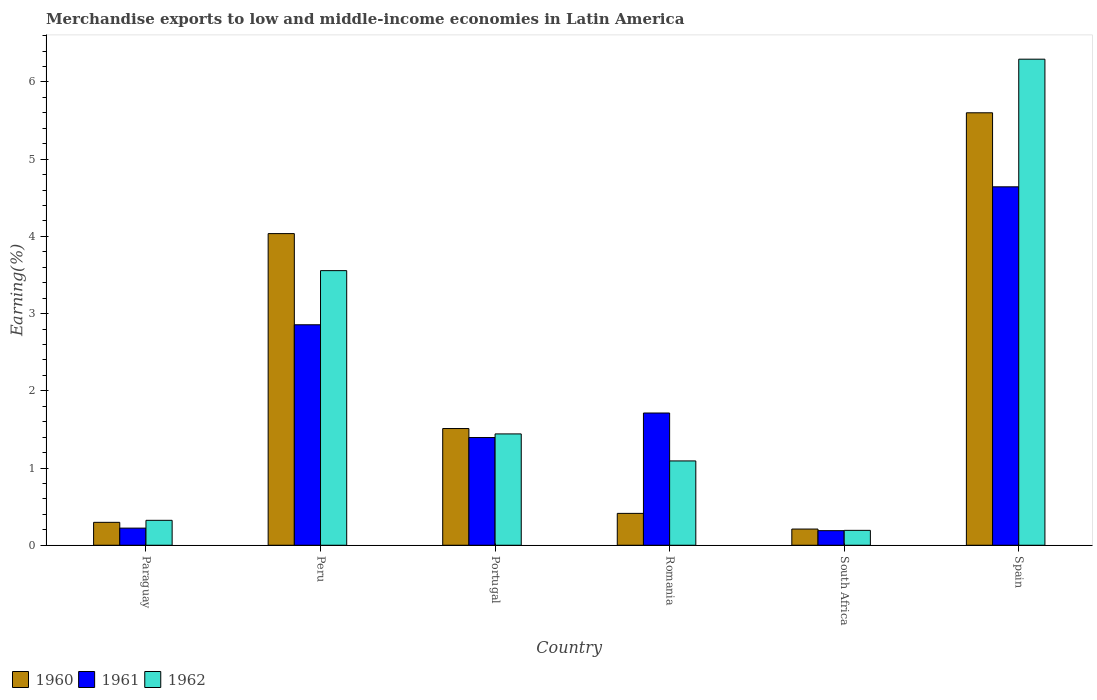How many different coloured bars are there?
Your answer should be compact. 3. Are the number of bars per tick equal to the number of legend labels?
Offer a terse response. Yes. Are the number of bars on each tick of the X-axis equal?
Give a very brief answer. Yes. How many bars are there on the 1st tick from the left?
Ensure brevity in your answer.  3. What is the label of the 4th group of bars from the left?
Ensure brevity in your answer.  Romania. In how many cases, is the number of bars for a given country not equal to the number of legend labels?
Your answer should be very brief. 0. What is the percentage of amount earned from merchandise exports in 1960 in Peru?
Ensure brevity in your answer.  4.04. Across all countries, what is the maximum percentage of amount earned from merchandise exports in 1960?
Your answer should be very brief. 5.6. Across all countries, what is the minimum percentage of amount earned from merchandise exports in 1961?
Your response must be concise. 0.19. In which country was the percentage of amount earned from merchandise exports in 1961 minimum?
Give a very brief answer. South Africa. What is the total percentage of amount earned from merchandise exports in 1962 in the graph?
Provide a succinct answer. 12.9. What is the difference between the percentage of amount earned from merchandise exports in 1962 in Peru and that in Romania?
Offer a very short reply. 2.46. What is the difference between the percentage of amount earned from merchandise exports in 1962 in Peru and the percentage of amount earned from merchandise exports in 1960 in Spain?
Keep it short and to the point. -2.04. What is the average percentage of amount earned from merchandise exports in 1962 per country?
Your response must be concise. 2.15. What is the difference between the percentage of amount earned from merchandise exports of/in 1961 and percentage of amount earned from merchandise exports of/in 1960 in Peru?
Your answer should be very brief. -1.18. What is the ratio of the percentage of amount earned from merchandise exports in 1962 in Portugal to that in Spain?
Make the answer very short. 0.23. Is the difference between the percentage of amount earned from merchandise exports in 1961 in Romania and South Africa greater than the difference between the percentage of amount earned from merchandise exports in 1960 in Romania and South Africa?
Your response must be concise. Yes. What is the difference between the highest and the second highest percentage of amount earned from merchandise exports in 1960?
Give a very brief answer. -2.52. What is the difference between the highest and the lowest percentage of amount earned from merchandise exports in 1960?
Ensure brevity in your answer.  5.39. In how many countries, is the percentage of amount earned from merchandise exports in 1961 greater than the average percentage of amount earned from merchandise exports in 1961 taken over all countries?
Offer a very short reply. 2. What does the 3rd bar from the left in Peru represents?
Offer a very short reply. 1962. Is it the case that in every country, the sum of the percentage of amount earned from merchandise exports in 1962 and percentage of amount earned from merchandise exports in 1961 is greater than the percentage of amount earned from merchandise exports in 1960?
Offer a very short reply. Yes. How many bars are there?
Your answer should be very brief. 18. What is the difference between two consecutive major ticks on the Y-axis?
Offer a very short reply. 1. How many legend labels are there?
Make the answer very short. 3. How are the legend labels stacked?
Give a very brief answer. Horizontal. What is the title of the graph?
Provide a short and direct response. Merchandise exports to low and middle-income economies in Latin America. What is the label or title of the Y-axis?
Your response must be concise. Earning(%). What is the Earning(%) in 1960 in Paraguay?
Your answer should be very brief. 0.3. What is the Earning(%) of 1961 in Paraguay?
Provide a short and direct response. 0.22. What is the Earning(%) of 1962 in Paraguay?
Your answer should be compact. 0.32. What is the Earning(%) of 1960 in Peru?
Provide a succinct answer. 4.04. What is the Earning(%) in 1961 in Peru?
Your response must be concise. 2.86. What is the Earning(%) in 1962 in Peru?
Ensure brevity in your answer.  3.56. What is the Earning(%) in 1960 in Portugal?
Offer a terse response. 1.51. What is the Earning(%) in 1961 in Portugal?
Provide a short and direct response. 1.39. What is the Earning(%) of 1962 in Portugal?
Your response must be concise. 1.44. What is the Earning(%) in 1960 in Romania?
Keep it short and to the point. 0.41. What is the Earning(%) of 1961 in Romania?
Provide a succinct answer. 1.71. What is the Earning(%) of 1962 in Romania?
Provide a succinct answer. 1.09. What is the Earning(%) in 1960 in South Africa?
Your answer should be compact. 0.21. What is the Earning(%) in 1961 in South Africa?
Provide a short and direct response. 0.19. What is the Earning(%) of 1962 in South Africa?
Your answer should be very brief. 0.19. What is the Earning(%) of 1960 in Spain?
Provide a short and direct response. 5.6. What is the Earning(%) of 1961 in Spain?
Ensure brevity in your answer.  4.64. What is the Earning(%) of 1962 in Spain?
Give a very brief answer. 6.3. Across all countries, what is the maximum Earning(%) of 1960?
Your answer should be very brief. 5.6. Across all countries, what is the maximum Earning(%) of 1961?
Provide a short and direct response. 4.64. Across all countries, what is the maximum Earning(%) in 1962?
Your answer should be very brief. 6.3. Across all countries, what is the minimum Earning(%) in 1960?
Your response must be concise. 0.21. Across all countries, what is the minimum Earning(%) of 1961?
Give a very brief answer. 0.19. Across all countries, what is the minimum Earning(%) of 1962?
Keep it short and to the point. 0.19. What is the total Earning(%) of 1960 in the graph?
Offer a terse response. 12.07. What is the total Earning(%) in 1961 in the graph?
Your answer should be very brief. 11.02. What is the total Earning(%) of 1962 in the graph?
Your response must be concise. 12.9. What is the difference between the Earning(%) in 1960 in Paraguay and that in Peru?
Your answer should be compact. -3.74. What is the difference between the Earning(%) in 1961 in Paraguay and that in Peru?
Provide a short and direct response. -2.63. What is the difference between the Earning(%) in 1962 in Paraguay and that in Peru?
Ensure brevity in your answer.  -3.23. What is the difference between the Earning(%) of 1960 in Paraguay and that in Portugal?
Your answer should be very brief. -1.21. What is the difference between the Earning(%) of 1961 in Paraguay and that in Portugal?
Your response must be concise. -1.17. What is the difference between the Earning(%) of 1962 in Paraguay and that in Portugal?
Your answer should be compact. -1.12. What is the difference between the Earning(%) of 1960 in Paraguay and that in Romania?
Offer a terse response. -0.12. What is the difference between the Earning(%) of 1961 in Paraguay and that in Romania?
Ensure brevity in your answer.  -1.49. What is the difference between the Earning(%) of 1962 in Paraguay and that in Romania?
Ensure brevity in your answer.  -0.77. What is the difference between the Earning(%) of 1960 in Paraguay and that in South Africa?
Your answer should be very brief. 0.09. What is the difference between the Earning(%) in 1961 in Paraguay and that in South Africa?
Provide a succinct answer. 0.03. What is the difference between the Earning(%) of 1962 in Paraguay and that in South Africa?
Your answer should be compact. 0.13. What is the difference between the Earning(%) in 1960 in Paraguay and that in Spain?
Ensure brevity in your answer.  -5.3. What is the difference between the Earning(%) in 1961 in Paraguay and that in Spain?
Provide a short and direct response. -4.42. What is the difference between the Earning(%) of 1962 in Paraguay and that in Spain?
Provide a succinct answer. -5.97. What is the difference between the Earning(%) in 1960 in Peru and that in Portugal?
Provide a short and direct response. 2.52. What is the difference between the Earning(%) in 1961 in Peru and that in Portugal?
Keep it short and to the point. 1.46. What is the difference between the Earning(%) in 1962 in Peru and that in Portugal?
Provide a succinct answer. 2.11. What is the difference between the Earning(%) in 1960 in Peru and that in Romania?
Offer a very short reply. 3.62. What is the difference between the Earning(%) of 1961 in Peru and that in Romania?
Keep it short and to the point. 1.14. What is the difference between the Earning(%) of 1962 in Peru and that in Romania?
Your answer should be compact. 2.46. What is the difference between the Earning(%) in 1960 in Peru and that in South Africa?
Offer a terse response. 3.83. What is the difference between the Earning(%) of 1961 in Peru and that in South Africa?
Ensure brevity in your answer.  2.67. What is the difference between the Earning(%) in 1962 in Peru and that in South Africa?
Your answer should be very brief. 3.36. What is the difference between the Earning(%) in 1960 in Peru and that in Spain?
Give a very brief answer. -1.56. What is the difference between the Earning(%) of 1961 in Peru and that in Spain?
Offer a very short reply. -1.79. What is the difference between the Earning(%) in 1962 in Peru and that in Spain?
Ensure brevity in your answer.  -2.74. What is the difference between the Earning(%) of 1960 in Portugal and that in Romania?
Ensure brevity in your answer.  1.1. What is the difference between the Earning(%) of 1961 in Portugal and that in Romania?
Your answer should be compact. -0.32. What is the difference between the Earning(%) of 1962 in Portugal and that in Romania?
Your answer should be compact. 0.35. What is the difference between the Earning(%) in 1960 in Portugal and that in South Africa?
Ensure brevity in your answer.  1.3. What is the difference between the Earning(%) in 1961 in Portugal and that in South Africa?
Your answer should be compact. 1.21. What is the difference between the Earning(%) of 1962 in Portugal and that in South Africa?
Keep it short and to the point. 1.25. What is the difference between the Earning(%) of 1960 in Portugal and that in Spain?
Ensure brevity in your answer.  -4.09. What is the difference between the Earning(%) of 1961 in Portugal and that in Spain?
Your answer should be very brief. -3.25. What is the difference between the Earning(%) in 1962 in Portugal and that in Spain?
Provide a short and direct response. -4.85. What is the difference between the Earning(%) in 1960 in Romania and that in South Africa?
Offer a very short reply. 0.2. What is the difference between the Earning(%) of 1961 in Romania and that in South Africa?
Your answer should be compact. 1.52. What is the difference between the Earning(%) in 1962 in Romania and that in South Africa?
Offer a terse response. 0.9. What is the difference between the Earning(%) of 1960 in Romania and that in Spain?
Your answer should be very brief. -5.19. What is the difference between the Earning(%) in 1961 in Romania and that in Spain?
Ensure brevity in your answer.  -2.93. What is the difference between the Earning(%) in 1962 in Romania and that in Spain?
Your answer should be compact. -5.2. What is the difference between the Earning(%) in 1960 in South Africa and that in Spain?
Offer a terse response. -5.39. What is the difference between the Earning(%) in 1961 in South Africa and that in Spain?
Ensure brevity in your answer.  -4.45. What is the difference between the Earning(%) in 1962 in South Africa and that in Spain?
Provide a short and direct response. -6.1. What is the difference between the Earning(%) in 1960 in Paraguay and the Earning(%) in 1961 in Peru?
Ensure brevity in your answer.  -2.56. What is the difference between the Earning(%) in 1960 in Paraguay and the Earning(%) in 1962 in Peru?
Provide a succinct answer. -3.26. What is the difference between the Earning(%) in 1961 in Paraguay and the Earning(%) in 1962 in Peru?
Make the answer very short. -3.33. What is the difference between the Earning(%) of 1960 in Paraguay and the Earning(%) of 1961 in Portugal?
Your answer should be very brief. -1.1. What is the difference between the Earning(%) of 1960 in Paraguay and the Earning(%) of 1962 in Portugal?
Give a very brief answer. -1.15. What is the difference between the Earning(%) of 1961 in Paraguay and the Earning(%) of 1962 in Portugal?
Your answer should be very brief. -1.22. What is the difference between the Earning(%) in 1960 in Paraguay and the Earning(%) in 1961 in Romania?
Provide a short and direct response. -1.42. What is the difference between the Earning(%) in 1960 in Paraguay and the Earning(%) in 1962 in Romania?
Give a very brief answer. -0.8. What is the difference between the Earning(%) in 1961 in Paraguay and the Earning(%) in 1962 in Romania?
Your answer should be very brief. -0.87. What is the difference between the Earning(%) in 1960 in Paraguay and the Earning(%) in 1961 in South Africa?
Offer a terse response. 0.11. What is the difference between the Earning(%) in 1960 in Paraguay and the Earning(%) in 1962 in South Africa?
Your answer should be very brief. 0.1. What is the difference between the Earning(%) of 1961 in Paraguay and the Earning(%) of 1962 in South Africa?
Offer a terse response. 0.03. What is the difference between the Earning(%) in 1960 in Paraguay and the Earning(%) in 1961 in Spain?
Make the answer very short. -4.35. What is the difference between the Earning(%) in 1960 in Paraguay and the Earning(%) in 1962 in Spain?
Provide a short and direct response. -6. What is the difference between the Earning(%) in 1961 in Paraguay and the Earning(%) in 1962 in Spain?
Give a very brief answer. -6.07. What is the difference between the Earning(%) of 1960 in Peru and the Earning(%) of 1961 in Portugal?
Offer a very short reply. 2.64. What is the difference between the Earning(%) of 1960 in Peru and the Earning(%) of 1962 in Portugal?
Give a very brief answer. 2.59. What is the difference between the Earning(%) in 1961 in Peru and the Earning(%) in 1962 in Portugal?
Offer a very short reply. 1.41. What is the difference between the Earning(%) of 1960 in Peru and the Earning(%) of 1961 in Romania?
Your answer should be very brief. 2.32. What is the difference between the Earning(%) in 1960 in Peru and the Earning(%) in 1962 in Romania?
Make the answer very short. 2.94. What is the difference between the Earning(%) of 1961 in Peru and the Earning(%) of 1962 in Romania?
Your answer should be compact. 1.76. What is the difference between the Earning(%) of 1960 in Peru and the Earning(%) of 1961 in South Africa?
Keep it short and to the point. 3.85. What is the difference between the Earning(%) in 1960 in Peru and the Earning(%) in 1962 in South Africa?
Give a very brief answer. 3.84. What is the difference between the Earning(%) in 1961 in Peru and the Earning(%) in 1962 in South Africa?
Make the answer very short. 2.66. What is the difference between the Earning(%) of 1960 in Peru and the Earning(%) of 1961 in Spain?
Offer a very short reply. -0.61. What is the difference between the Earning(%) of 1960 in Peru and the Earning(%) of 1962 in Spain?
Your response must be concise. -2.26. What is the difference between the Earning(%) in 1961 in Peru and the Earning(%) in 1962 in Spain?
Offer a terse response. -3.44. What is the difference between the Earning(%) in 1960 in Portugal and the Earning(%) in 1961 in Romania?
Make the answer very short. -0.2. What is the difference between the Earning(%) in 1960 in Portugal and the Earning(%) in 1962 in Romania?
Your response must be concise. 0.42. What is the difference between the Earning(%) in 1961 in Portugal and the Earning(%) in 1962 in Romania?
Offer a very short reply. 0.3. What is the difference between the Earning(%) of 1960 in Portugal and the Earning(%) of 1961 in South Africa?
Provide a succinct answer. 1.32. What is the difference between the Earning(%) of 1960 in Portugal and the Earning(%) of 1962 in South Africa?
Offer a terse response. 1.32. What is the difference between the Earning(%) in 1961 in Portugal and the Earning(%) in 1962 in South Africa?
Make the answer very short. 1.2. What is the difference between the Earning(%) of 1960 in Portugal and the Earning(%) of 1961 in Spain?
Offer a terse response. -3.13. What is the difference between the Earning(%) of 1960 in Portugal and the Earning(%) of 1962 in Spain?
Your answer should be compact. -4.78. What is the difference between the Earning(%) of 1961 in Portugal and the Earning(%) of 1962 in Spain?
Provide a short and direct response. -4.9. What is the difference between the Earning(%) of 1960 in Romania and the Earning(%) of 1961 in South Africa?
Offer a terse response. 0.22. What is the difference between the Earning(%) in 1960 in Romania and the Earning(%) in 1962 in South Africa?
Give a very brief answer. 0.22. What is the difference between the Earning(%) in 1961 in Romania and the Earning(%) in 1962 in South Africa?
Offer a terse response. 1.52. What is the difference between the Earning(%) of 1960 in Romania and the Earning(%) of 1961 in Spain?
Offer a terse response. -4.23. What is the difference between the Earning(%) in 1960 in Romania and the Earning(%) in 1962 in Spain?
Offer a terse response. -5.88. What is the difference between the Earning(%) of 1961 in Romania and the Earning(%) of 1962 in Spain?
Your answer should be very brief. -4.58. What is the difference between the Earning(%) of 1960 in South Africa and the Earning(%) of 1961 in Spain?
Ensure brevity in your answer.  -4.43. What is the difference between the Earning(%) of 1960 in South Africa and the Earning(%) of 1962 in Spain?
Your response must be concise. -6.09. What is the difference between the Earning(%) in 1961 in South Africa and the Earning(%) in 1962 in Spain?
Offer a very short reply. -6.11. What is the average Earning(%) in 1960 per country?
Offer a terse response. 2.01. What is the average Earning(%) in 1961 per country?
Keep it short and to the point. 1.84. What is the average Earning(%) of 1962 per country?
Your response must be concise. 2.15. What is the difference between the Earning(%) in 1960 and Earning(%) in 1961 in Paraguay?
Provide a short and direct response. 0.07. What is the difference between the Earning(%) in 1960 and Earning(%) in 1962 in Paraguay?
Offer a very short reply. -0.03. What is the difference between the Earning(%) of 1961 and Earning(%) of 1962 in Paraguay?
Ensure brevity in your answer.  -0.1. What is the difference between the Earning(%) in 1960 and Earning(%) in 1961 in Peru?
Offer a terse response. 1.18. What is the difference between the Earning(%) in 1960 and Earning(%) in 1962 in Peru?
Make the answer very short. 0.48. What is the difference between the Earning(%) in 1961 and Earning(%) in 1962 in Peru?
Provide a succinct answer. -0.7. What is the difference between the Earning(%) in 1960 and Earning(%) in 1961 in Portugal?
Your response must be concise. 0.12. What is the difference between the Earning(%) of 1960 and Earning(%) of 1962 in Portugal?
Offer a very short reply. 0.07. What is the difference between the Earning(%) of 1961 and Earning(%) of 1962 in Portugal?
Ensure brevity in your answer.  -0.05. What is the difference between the Earning(%) in 1960 and Earning(%) in 1961 in Romania?
Offer a terse response. -1.3. What is the difference between the Earning(%) in 1960 and Earning(%) in 1962 in Romania?
Your answer should be very brief. -0.68. What is the difference between the Earning(%) in 1961 and Earning(%) in 1962 in Romania?
Offer a very short reply. 0.62. What is the difference between the Earning(%) in 1960 and Earning(%) in 1961 in South Africa?
Offer a terse response. 0.02. What is the difference between the Earning(%) of 1960 and Earning(%) of 1962 in South Africa?
Your answer should be compact. 0.02. What is the difference between the Earning(%) in 1961 and Earning(%) in 1962 in South Africa?
Offer a terse response. -0. What is the difference between the Earning(%) of 1960 and Earning(%) of 1961 in Spain?
Provide a short and direct response. 0.96. What is the difference between the Earning(%) of 1960 and Earning(%) of 1962 in Spain?
Ensure brevity in your answer.  -0.69. What is the difference between the Earning(%) in 1961 and Earning(%) in 1962 in Spain?
Keep it short and to the point. -1.65. What is the ratio of the Earning(%) in 1960 in Paraguay to that in Peru?
Provide a succinct answer. 0.07. What is the ratio of the Earning(%) of 1961 in Paraguay to that in Peru?
Your answer should be compact. 0.08. What is the ratio of the Earning(%) of 1962 in Paraguay to that in Peru?
Give a very brief answer. 0.09. What is the ratio of the Earning(%) of 1960 in Paraguay to that in Portugal?
Keep it short and to the point. 0.2. What is the ratio of the Earning(%) in 1961 in Paraguay to that in Portugal?
Keep it short and to the point. 0.16. What is the ratio of the Earning(%) of 1962 in Paraguay to that in Portugal?
Make the answer very short. 0.22. What is the ratio of the Earning(%) of 1960 in Paraguay to that in Romania?
Give a very brief answer. 0.72. What is the ratio of the Earning(%) in 1961 in Paraguay to that in Romania?
Offer a very short reply. 0.13. What is the ratio of the Earning(%) of 1962 in Paraguay to that in Romania?
Provide a short and direct response. 0.3. What is the ratio of the Earning(%) of 1960 in Paraguay to that in South Africa?
Provide a short and direct response. 1.42. What is the ratio of the Earning(%) in 1961 in Paraguay to that in South Africa?
Provide a succinct answer. 1.17. What is the ratio of the Earning(%) in 1962 in Paraguay to that in South Africa?
Offer a very short reply. 1.67. What is the ratio of the Earning(%) of 1960 in Paraguay to that in Spain?
Provide a short and direct response. 0.05. What is the ratio of the Earning(%) in 1961 in Paraguay to that in Spain?
Provide a succinct answer. 0.05. What is the ratio of the Earning(%) in 1962 in Paraguay to that in Spain?
Ensure brevity in your answer.  0.05. What is the ratio of the Earning(%) in 1960 in Peru to that in Portugal?
Give a very brief answer. 2.67. What is the ratio of the Earning(%) of 1961 in Peru to that in Portugal?
Give a very brief answer. 2.05. What is the ratio of the Earning(%) of 1962 in Peru to that in Portugal?
Offer a terse response. 2.47. What is the ratio of the Earning(%) in 1960 in Peru to that in Romania?
Make the answer very short. 9.78. What is the ratio of the Earning(%) of 1961 in Peru to that in Romania?
Provide a succinct answer. 1.67. What is the ratio of the Earning(%) of 1962 in Peru to that in Romania?
Ensure brevity in your answer.  3.26. What is the ratio of the Earning(%) in 1960 in Peru to that in South Africa?
Your response must be concise. 19.26. What is the ratio of the Earning(%) of 1961 in Peru to that in South Africa?
Your response must be concise. 15.13. What is the ratio of the Earning(%) in 1962 in Peru to that in South Africa?
Provide a short and direct response. 18.46. What is the ratio of the Earning(%) in 1960 in Peru to that in Spain?
Keep it short and to the point. 0.72. What is the ratio of the Earning(%) in 1961 in Peru to that in Spain?
Offer a terse response. 0.62. What is the ratio of the Earning(%) in 1962 in Peru to that in Spain?
Your response must be concise. 0.56. What is the ratio of the Earning(%) of 1960 in Portugal to that in Romania?
Your answer should be very brief. 3.66. What is the ratio of the Earning(%) of 1961 in Portugal to that in Romania?
Provide a succinct answer. 0.81. What is the ratio of the Earning(%) of 1962 in Portugal to that in Romania?
Keep it short and to the point. 1.32. What is the ratio of the Earning(%) of 1960 in Portugal to that in South Africa?
Offer a very short reply. 7.21. What is the ratio of the Earning(%) of 1961 in Portugal to that in South Africa?
Offer a very short reply. 7.39. What is the ratio of the Earning(%) of 1962 in Portugal to that in South Africa?
Provide a short and direct response. 7.48. What is the ratio of the Earning(%) in 1960 in Portugal to that in Spain?
Give a very brief answer. 0.27. What is the ratio of the Earning(%) in 1961 in Portugal to that in Spain?
Your answer should be compact. 0.3. What is the ratio of the Earning(%) of 1962 in Portugal to that in Spain?
Your response must be concise. 0.23. What is the ratio of the Earning(%) in 1960 in Romania to that in South Africa?
Ensure brevity in your answer.  1.97. What is the ratio of the Earning(%) in 1961 in Romania to that in South Africa?
Keep it short and to the point. 9.07. What is the ratio of the Earning(%) in 1962 in Romania to that in South Africa?
Your response must be concise. 5.67. What is the ratio of the Earning(%) of 1960 in Romania to that in Spain?
Your answer should be compact. 0.07. What is the ratio of the Earning(%) of 1961 in Romania to that in Spain?
Ensure brevity in your answer.  0.37. What is the ratio of the Earning(%) in 1962 in Romania to that in Spain?
Provide a short and direct response. 0.17. What is the ratio of the Earning(%) of 1960 in South Africa to that in Spain?
Give a very brief answer. 0.04. What is the ratio of the Earning(%) of 1961 in South Africa to that in Spain?
Your answer should be very brief. 0.04. What is the ratio of the Earning(%) of 1962 in South Africa to that in Spain?
Your answer should be very brief. 0.03. What is the difference between the highest and the second highest Earning(%) of 1960?
Offer a terse response. 1.56. What is the difference between the highest and the second highest Earning(%) of 1961?
Provide a short and direct response. 1.79. What is the difference between the highest and the second highest Earning(%) of 1962?
Provide a succinct answer. 2.74. What is the difference between the highest and the lowest Earning(%) of 1960?
Keep it short and to the point. 5.39. What is the difference between the highest and the lowest Earning(%) in 1961?
Your answer should be compact. 4.45. What is the difference between the highest and the lowest Earning(%) of 1962?
Keep it short and to the point. 6.1. 